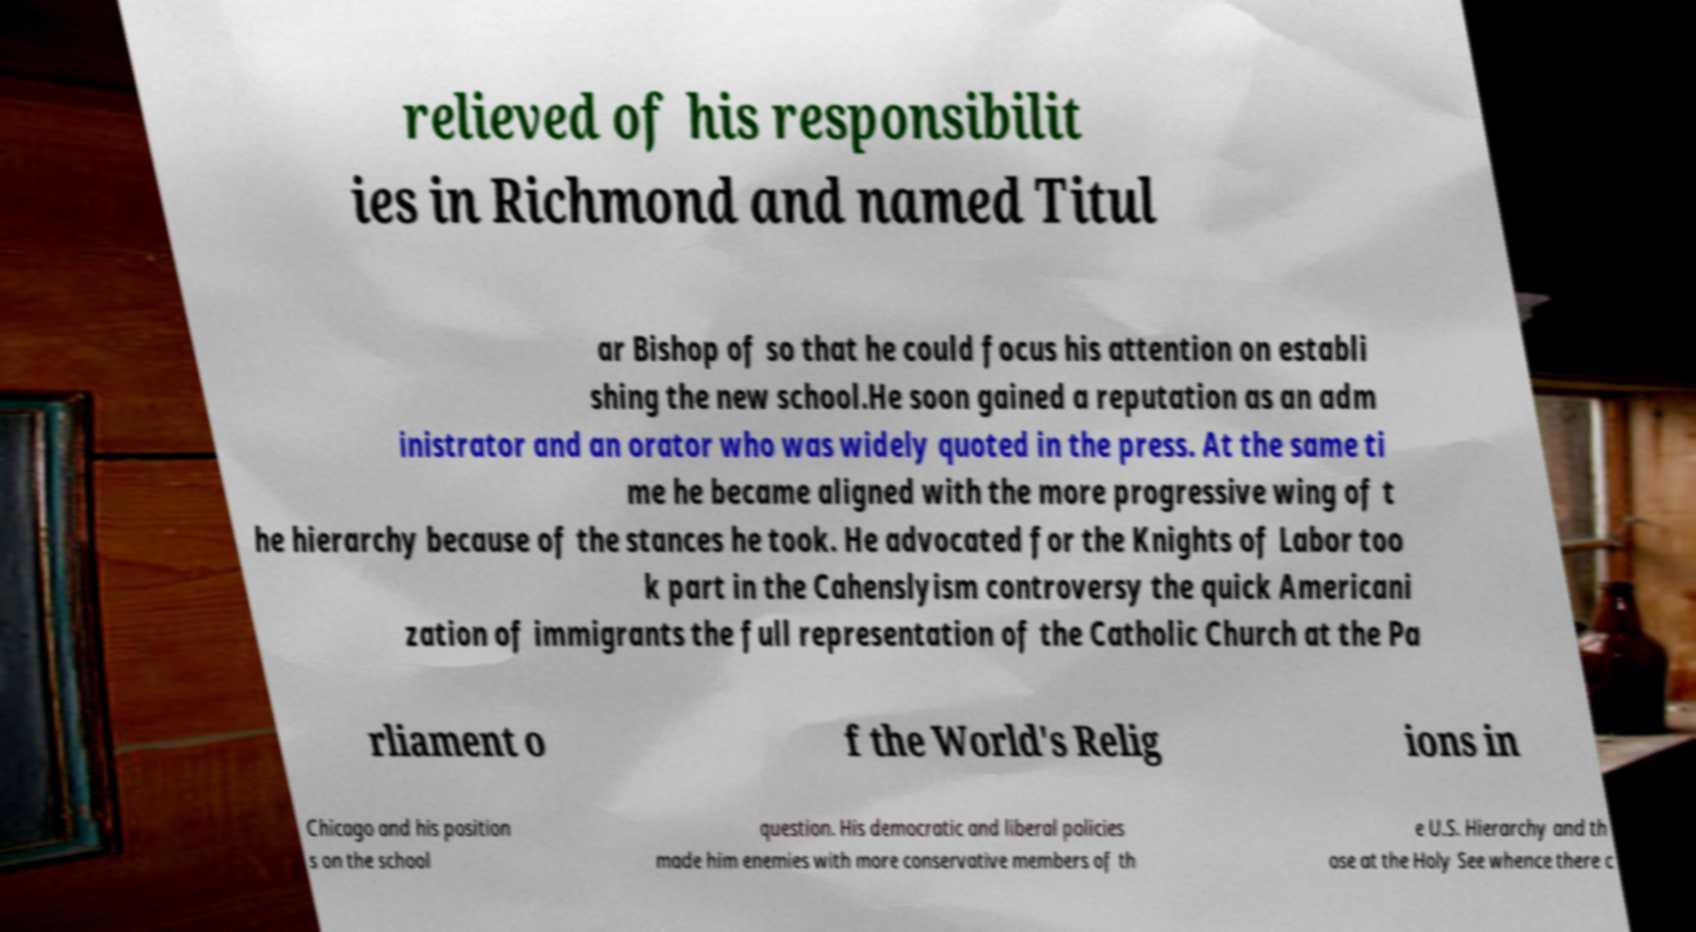Can you read and provide the text displayed in the image?This photo seems to have some interesting text. Can you extract and type it out for me? relieved of his responsibilit ies in Richmond and named Titul ar Bishop of so that he could focus his attention on establi shing the new school.He soon gained a reputation as an adm inistrator and an orator who was widely quoted in the press. At the same ti me he became aligned with the more progressive wing of t he hierarchy because of the stances he took. He advocated for the Knights of Labor too k part in the Cahenslyism controversy the quick Americani zation of immigrants the full representation of the Catholic Church at the Pa rliament o f the World's Relig ions in Chicago and his position s on the school question. His democratic and liberal policies made him enemies with more conservative members of th e U.S. Hierarchy and th ose at the Holy See whence there c 